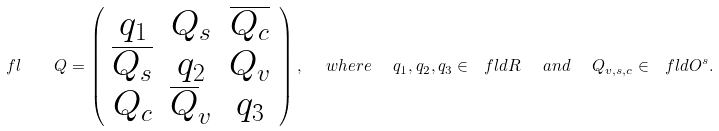Convert formula to latex. <formula><loc_0><loc_0><loc_500><loc_500>\ f l \quad Q = \left ( \begin{array} { c c c } q _ { 1 } & Q _ { s } & \overline { Q _ { c } } \\ \overline { Q _ { s } } & q _ { 2 } & Q _ { v } \\ Q _ { c } & \overline { Q } _ { v } & q _ { 3 } \end{array} \right ) , \ \ w h e r e \ \ q _ { 1 } , q _ { 2 } , q _ { 3 } \in \ f l d { R } \ \ a n d \ \ Q _ { v , s , c } \in \ f l d { O } ^ { s } .</formula> 